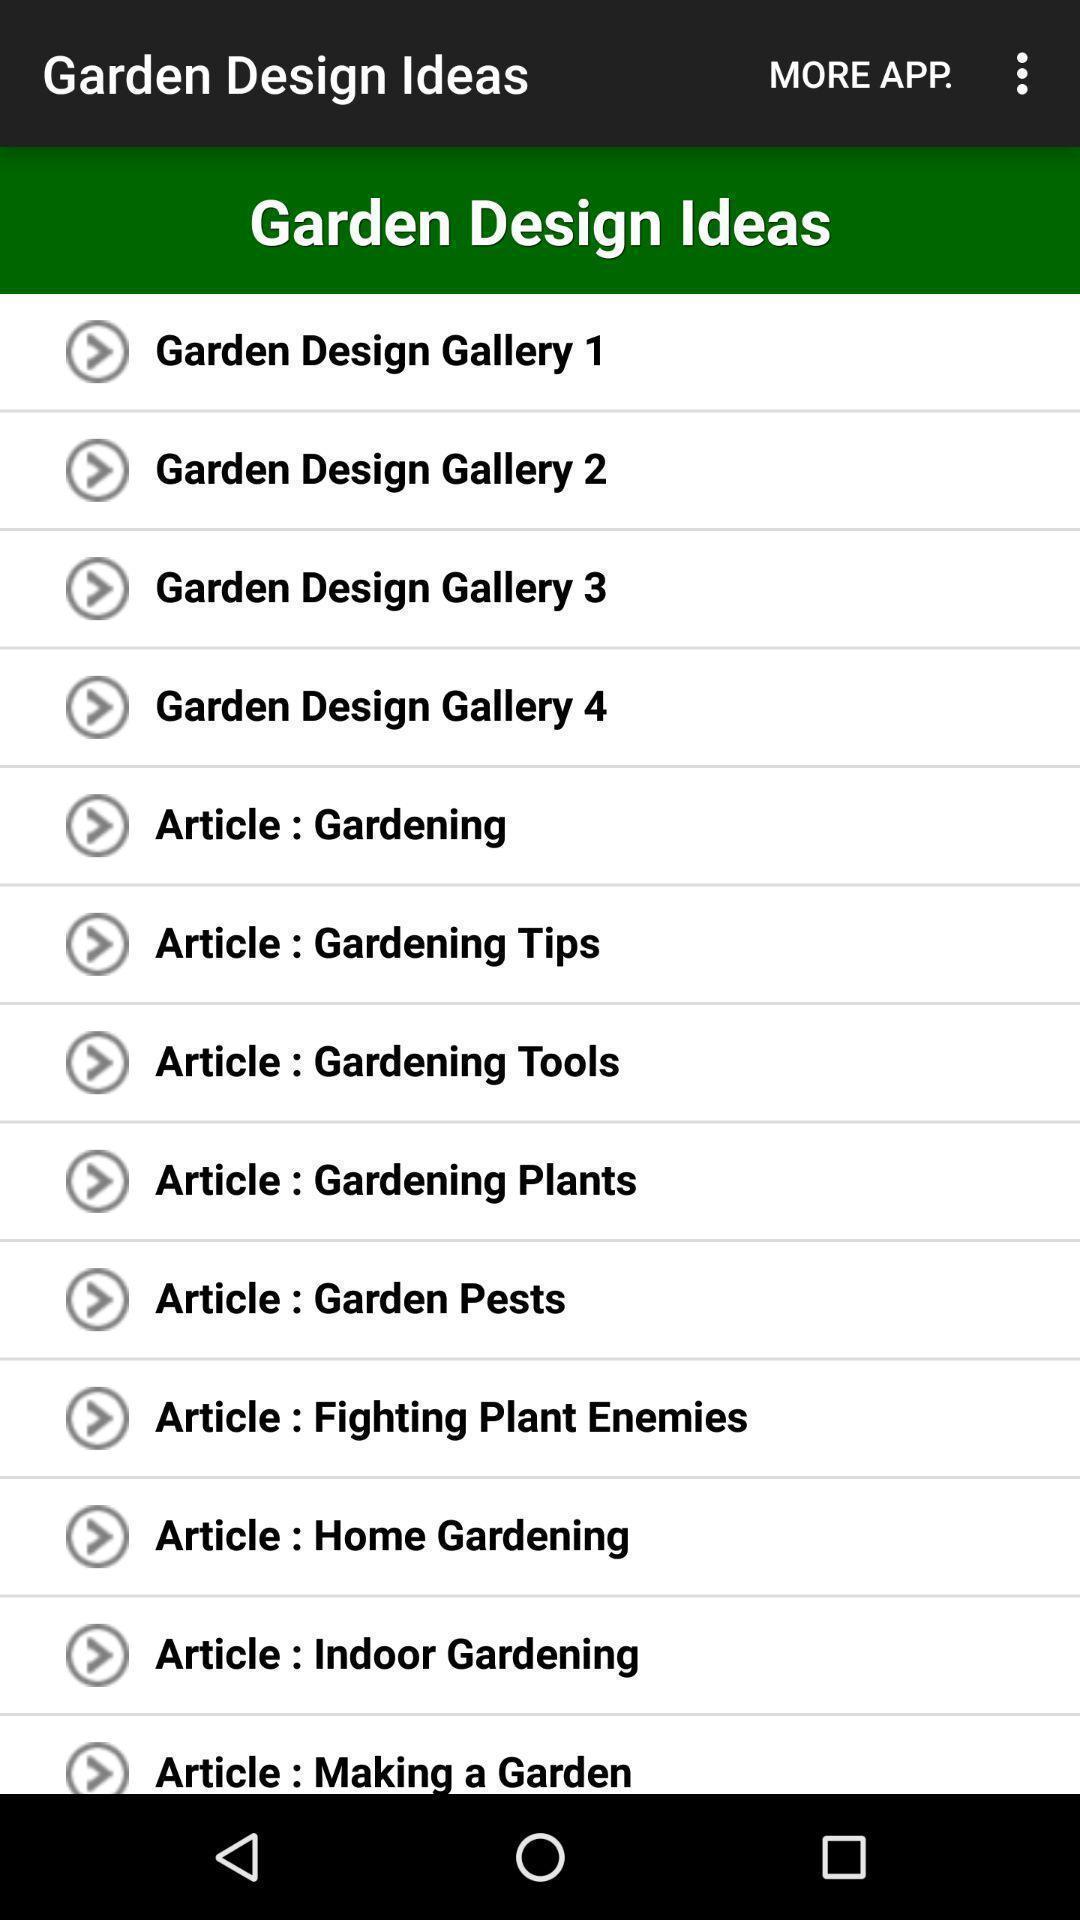Describe the content in this image. Screen display shows about saving and sharing designs. 